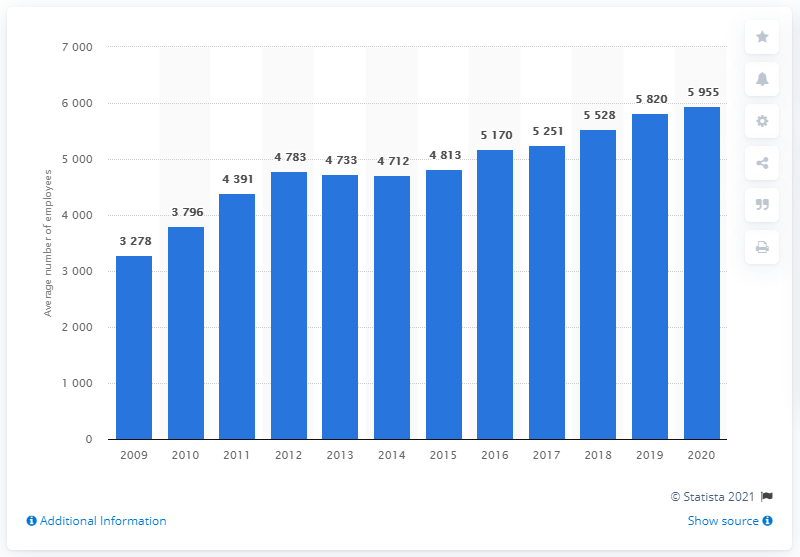Outline some significant characteristics in this image. In 2020, Leo Pharma had the highest number of full-time employees. 